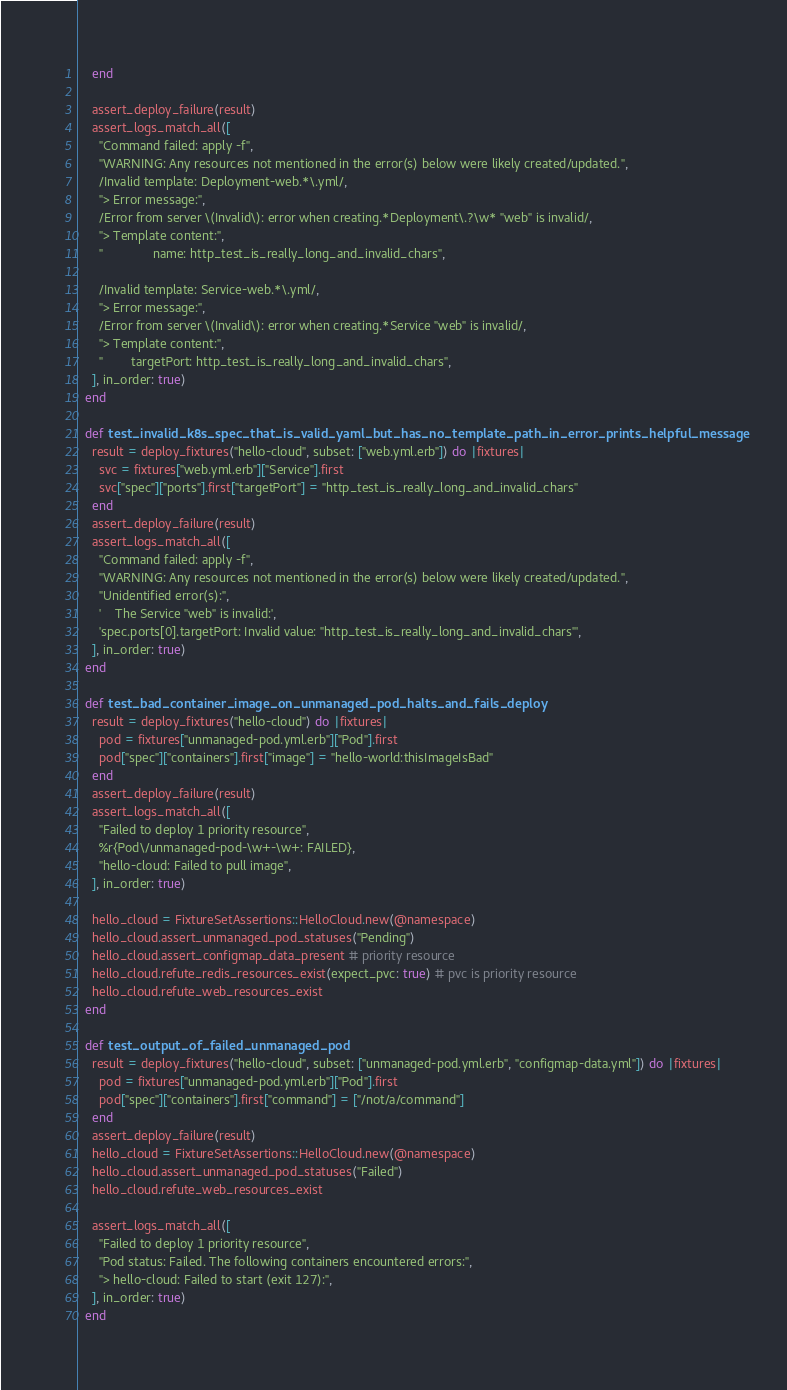Convert code to text. <code><loc_0><loc_0><loc_500><loc_500><_Ruby_>    end

    assert_deploy_failure(result)
    assert_logs_match_all([
      "Command failed: apply -f",
      "WARNING: Any resources not mentioned in the error(s) below were likely created/updated.",
      /Invalid template: Deployment-web.*\.yml/,
      "> Error message:",
      /Error from server \(Invalid\): error when creating.*Deployment\.?\w* "web" is invalid/,
      "> Template content:",
      "              name: http_test_is_really_long_and_invalid_chars",

      /Invalid template: Service-web.*\.yml/,
      "> Error message:",
      /Error from server \(Invalid\): error when creating.*Service "web" is invalid/,
      "> Template content:",
      "        targetPort: http_test_is_really_long_and_invalid_chars",
    ], in_order: true)
  end

  def test_invalid_k8s_spec_that_is_valid_yaml_but_has_no_template_path_in_error_prints_helpful_message
    result = deploy_fixtures("hello-cloud", subset: ["web.yml.erb"]) do |fixtures|
      svc = fixtures["web.yml.erb"]["Service"].first
      svc["spec"]["ports"].first["targetPort"] = "http_test_is_really_long_and_invalid_chars"
    end
    assert_deploy_failure(result)
    assert_logs_match_all([
      "Command failed: apply -f",
      "WARNING: Any resources not mentioned in the error(s) below were likely created/updated.",
      "Unidentified error(s):",
      '    The Service "web" is invalid:',
      'spec.ports[0].targetPort: Invalid value: "http_test_is_really_long_and_invalid_chars"',
    ], in_order: true)
  end

  def test_bad_container_image_on_unmanaged_pod_halts_and_fails_deploy
    result = deploy_fixtures("hello-cloud") do |fixtures|
      pod = fixtures["unmanaged-pod.yml.erb"]["Pod"].first
      pod["spec"]["containers"].first["image"] = "hello-world:thisImageIsBad"
    end
    assert_deploy_failure(result)
    assert_logs_match_all([
      "Failed to deploy 1 priority resource",
      %r{Pod\/unmanaged-pod-\w+-\w+: FAILED},
      "hello-cloud: Failed to pull image",
    ], in_order: true)

    hello_cloud = FixtureSetAssertions::HelloCloud.new(@namespace)
    hello_cloud.assert_unmanaged_pod_statuses("Pending")
    hello_cloud.assert_configmap_data_present # priority resource
    hello_cloud.refute_redis_resources_exist(expect_pvc: true) # pvc is priority resource
    hello_cloud.refute_web_resources_exist
  end

  def test_output_of_failed_unmanaged_pod
    result = deploy_fixtures("hello-cloud", subset: ["unmanaged-pod.yml.erb", "configmap-data.yml"]) do |fixtures|
      pod = fixtures["unmanaged-pod.yml.erb"]["Pod"].first
      pod["spec"]["containers"].first["command"] = ["/not/a/command"]
    end
    assert_deploy_failure(result)
    hello_cloud = FixtureSetAssertions::HelloCloud.new(@namespace)
    hello_cloud.assert_unmanaged_pod_statuses("Failed")
    hello_cloud.refute_web_resources_exist

    assert_logs_match_all([
      "Failed to deploy 1 priority resource",
      "Pod status: Failed. The following containers encountered errors:",
      "> hello-cloud: Failed to start (exit 127):",
    ], in_order: true)
  end
</code> 